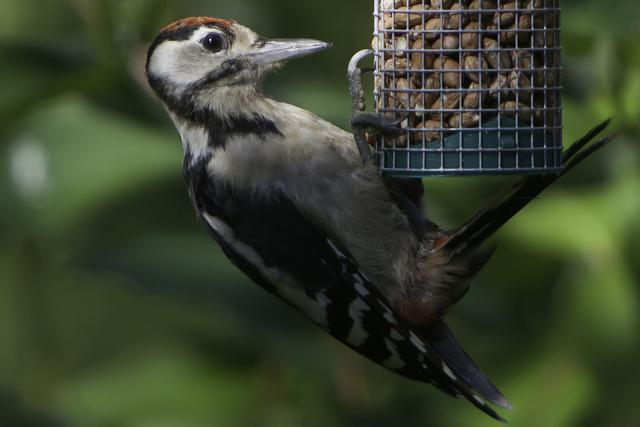What bird is this?
Keep it brief. Woodpecker. What species of bird is on the left?
Concise answer only. Woodpecker. Where is the bird in the picture?
Answer briefly. Feeder. What famous cartoon character is this?
Write a very short answer. Woody woodpecker. What is the bird eating?
Answer briefly. Nuts. Where is the bird perched?
Concise answer only. Bird feeder. What type of bird is this?
Quick response, please. Woodpecker. Is this bird sitting on a branch?
Concise answer only. No. What species is the bird?
Write a very short answer. Woodpecker. What kind of bird is this?
Answer briefly. Woodpecker. Does this bird want to eat the nuts?
Be succinct. Yes. Where is the bird?
Quick response, please. Feeder. Is the bird eating?
Answer briefly. Yes. What color is the birds cheek feathers?
Quick response, please. Gray. What is the bird sitting on?
Keep it brief. Bird feeder. Is this bird eating?
Quick response, please. Yes. What color is the bird?
Be succinct. Black and white. 